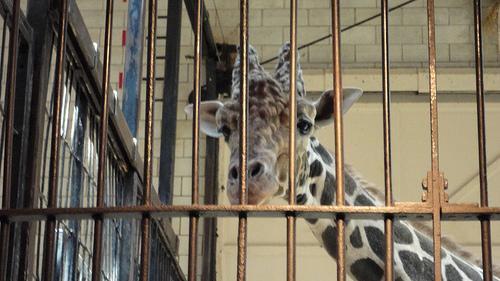How many giraffes are there?
Give a very brief answer. 1. 